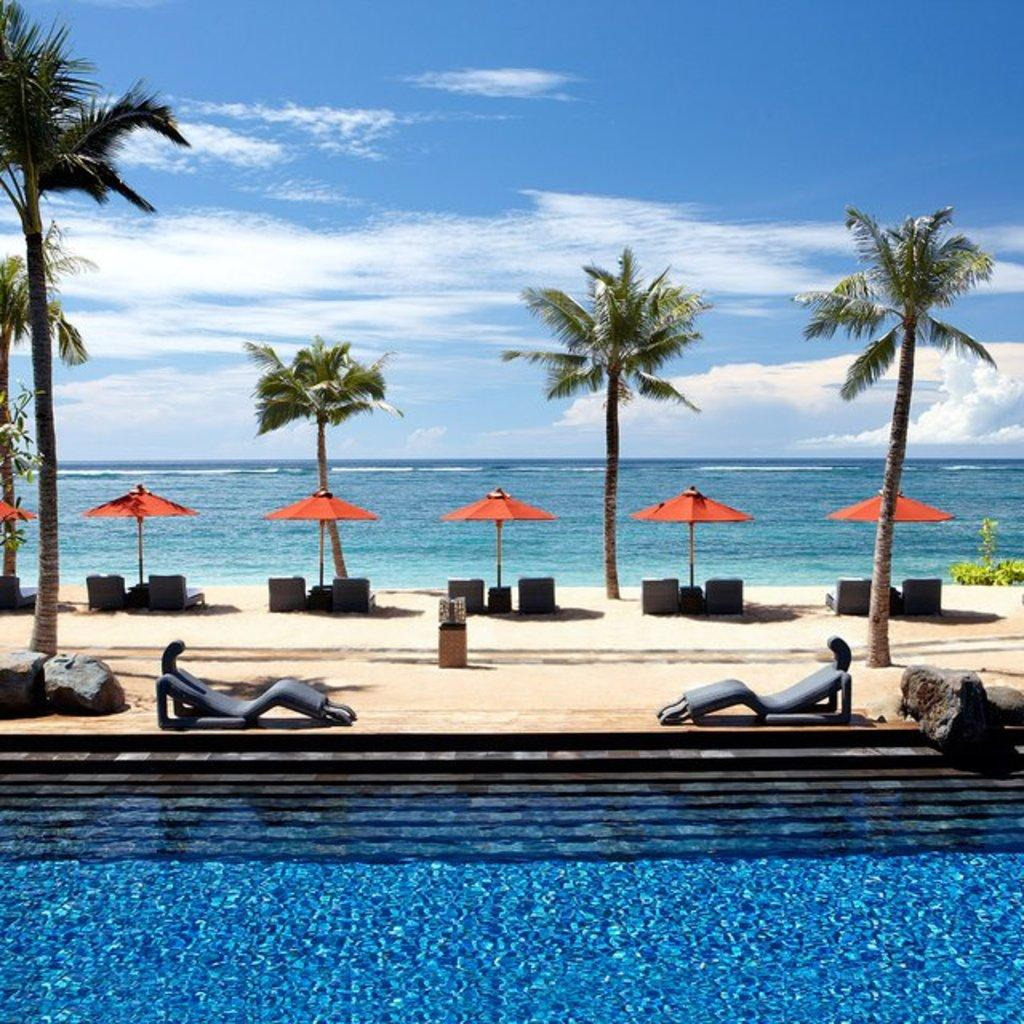What is one of the main elements in the image? There is water in the image. What type of furniture can be seen in the image? There are chairs in the image. What type of natural elements are present in the image? There are trees, plants, and rocks in the image. What objects are used for shade in the image? There are umbrellas in the image. What is visible in the background of the image? The background of the image includes water and the sky. What can be seen in the sky in the image? Clouds are present in the sky. How many hands are visible in the image? There are no hands visible in the image. What type of vacation is being depicted in the image? The image does not depict a vacation; it shows a natural setting with water, trees, plants, rocks, umbrellas, and chairs. 